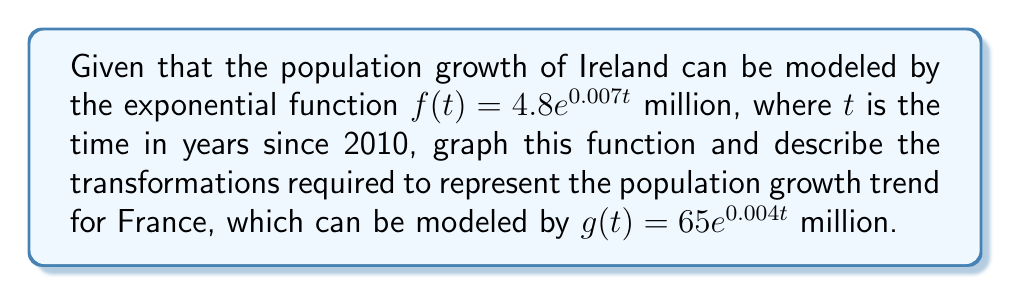Help me with this question. 1. Graph the function for Ireland: $f(t) = 4.8e^{0.007t}$
   - The base function is $y = e^x$
   - Vertical stretch by a factor of 4.8
   - Horizontal compression by a factor of 0.007

2. To transform $f(t)$ into $g(t)$ for France:
   a) Vertical stretch:
      - Multiply by $\frac{65}{4.8} \approx 13.54$
      $4.8e^{0.007t} \rightarrow 65e^{0.007t}$

   b) Horizontal stretch:
      - Multiply $t$ by $\frac{0.004}{0.007} \approx 0.571$
      $65e^{0.007t} \rightarrow 65e^{0.004t}$

3. Summary of transformations:
   - Vertical stretch by a factor of $\frac{65}{4.8} \approx 13.54$
   - Horizontal stretch by a factor of $\frac{0.007}{0.004} \approx 1.75$

[asy]
import graph;
size(200,150);

real f(real x) {return 4.8*exp(0.007*x);}
real g(real x) {return 65*exp(0.004*x);}

draw(graph(f,0,100),blue,legend="Ireland");
draw(graph(g,0,100),red,legend="France");

xaxis("Years since 2010",Bottom,LeftTicks);
yaxis("Population (millions)",Left,RightTicks);

add(legend());
[/asy]
Answer: Vertical stretch by 13.54, horizontal stretch by 1.75 